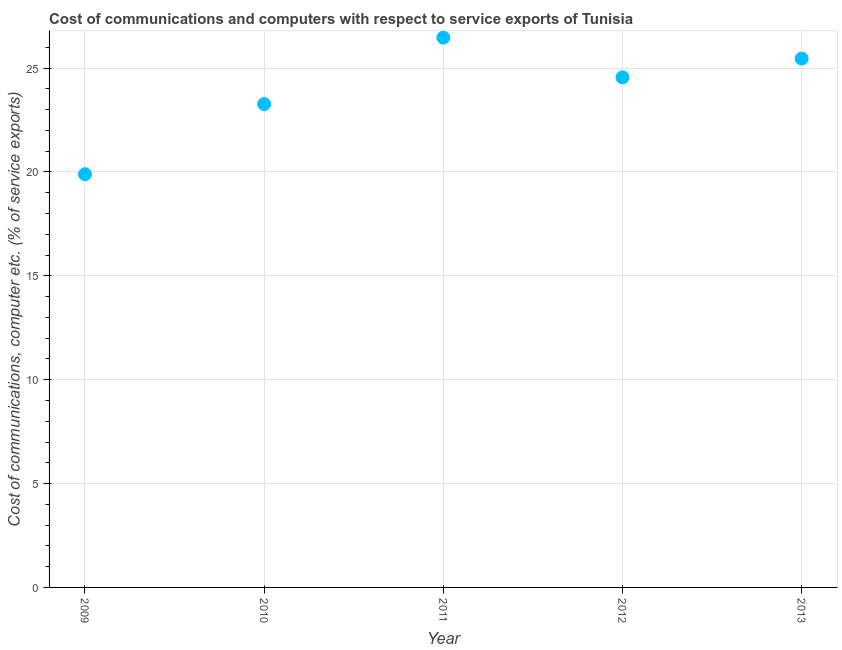What is the cost of communications and computer in 2012?
Offer a terse response. 24.55. Across all years, what is the maximum cost of communications and computer?
Your answer should be compact. 26.46. Across all years, what is the minimum cost of communications and computer?
Make the answer very short. 19.89. In which year was the cost of communications and computer minimum?
Provide a short and direct response. 2009. What is the sum of the cost of communications and computer?
Your answer should be compact. 119.63. What is the difference between the cost of communications and computer in 2010 and 2011?
Make the answer very short. -3.2. What is the average cost of communications and computer per year?
Ensure brevity in your answer.  23.93. What is the median cost of communications and computer?
Offer a terse response. 24.55. In how many years, is the cost of communications and computer greater than 17 %?
Your response must be concise. 5. Do a majority of the years between 2011 and 2013 (inclusive) have cost of communications and computer greater than 7 %?
Offer a terse response. Yes. What is the ratio of the cost of communications and computer in 2012 to that in 2013?
Your answer should be compact. 0.96. Is the cost of communications and computer in 2009 less than that in 2011?
Offer a very short reply. Yes. What is the difference between the highest and the second highest cost of communications and computer?
Keep it short and to the point. 1.01. Is the sum of the cost of communications and computer in 2009 and 2012 greater than the maximum cost of communications and computer across all years?
Your response must be concise. Yes. What is the difference between the highest and the lowest cost of communications and computer?
Your answer should be compact. 6.57. How many dotlines are there?
Offer a terse response. 1. How many years are there in the graph?
Offer a very short reply. 5. What is the difference between two consecutive major ticks on the Y-axis?
Offer a terse response. 5. Are the values on the major ticks of Y-axis written in scientific E-notation?
Offer a very short reply. No. What is the title of the graph?
Your response must be concise. Cost of communications and computers with respect to service exports of Tunisia. What is the label or title of the X-axis?
Your answer should be very brief. Year. What is the label or title of the Y-axis?
Your answer should be very brief. Cost of communications, computer etc. (% of service exports). What is the Cost of communications, computer etc. (% of service exports) in 2009?
Give a very brief answer. 19.89. What is the Cost of communications, computer etc. (% of service exports) in 2010?
Ensure brevity in your answer.  23.27. What is the Cost of communications, computer etc. (% of service exports) in 2011?
Give a very brief answer. 26.46. What is the Cost of communications, computer etc. (% of service exports) in 2012?
Provide a succinct answer. 24.55. What is the Cost of communications, computer etc. (% of service exports) in 2013?
Offer a terse response. 25.46. What is the difference between the Cost of communications, computer etc. (% of service exports) in 2009 and 2010?
Give a very brief answer. -3.38. What is the difference between the Cost of communications, computer etc. (% of service exports) in 2009 and 2011?
Provide a short and direct response. -6.57. What is the difference between the Cost of communications, computer etc. (% of service exports) in 2009 and 2012?
Keep it short and to the point. -4.66. What is the difference between the Cost of communications, computer etc. (% of service exports) in 2009 and 2013?
Offer a very short reply. -5.57. What is the difference between the Cost of communications, computer etc. (% of service exports) in 2010 and 2011?
Your response must be concise. -3.2. What is the difference between the Cost of communications, computer etc. (% of service exports) in 2010 and 2012?
Give a very brief answer. -1.28. What is the difference between the Cost of communications, computer etc. (% of service exports) in 2010 and 2013?
Offer a very short reply. -2.19. What is the difference between the Cost of communications, computer etc. (% of service exports) in 2011 and 2012?
Provide a short and direct response. 1.91. What is the difference between the Cost of communications, computer etc. (% of service exports) in 2011 and 2013?
Your answer should be compact. 1.01. What is the difference between the Cost of communications, computer etc. (% of service exports) in 2012 and 2013?
Ensure brevity in your answer.  -0.9. What is the ratio of the Cost of communications, computer etc. (% of service exports) in 2009 to that in 2010?
Make the answer very short. 0.85. What is the ratio of the Cost of communications, computer etc. (% of service exports) in 2009 to that in 2011?
Your answer should be very brief. 0.75. What is the ratio of the Cost of communications, computer etc. (% of service exports) in 2009 to that in 2012?
Make the answer very short. 0.81. What is the ratio of the Cost of communications, computer etc. (% of service exports) in 2009 to that in 2013?
Offer a very short reply. 0.78. What is the ratio of the Cost of communications, computer etc. (% of service exports) in 2010 to that in 2011?
Offer a very short reply. 0.88. What is the ratio of the Cost of communications, computer etc. (% of service exports) in 2010 to that in 2012?
Keep it short and to the point. 0.95. What is the ratio of the Cost of communications, computer etc. (% of service exports) in 2010 to that in 2013?
Give a very brief answer. 0.91. What is the ratio of the Cost of communications, computer etc. (% of service exports) in 2011 to that in 2012?
Ensure brevity in your answer.  1.08. What is the ratio of the Cost of communications, computer etc. (% of service exports) in 2011 to that in 2013?
Provide a succinct answer. 1.04. 